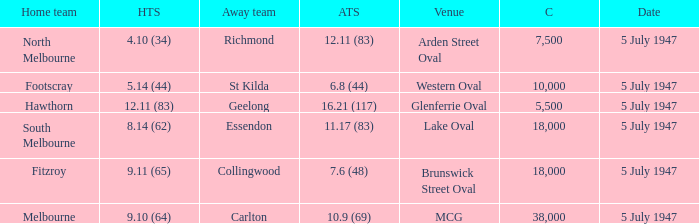Who was the away team when North Melbourne was the home team? Richmond. 